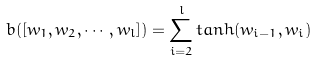<formula> <loc_0><loc_0><loc_500><loc_500>b ( [ w _ { 1 } , w _ { 2 } , \cdots , w _ { l } ] ) = \sum _ { i = 2 } ^ { l } t a n h ( w _ { i - 1 } , w _ { i } )</formula> 